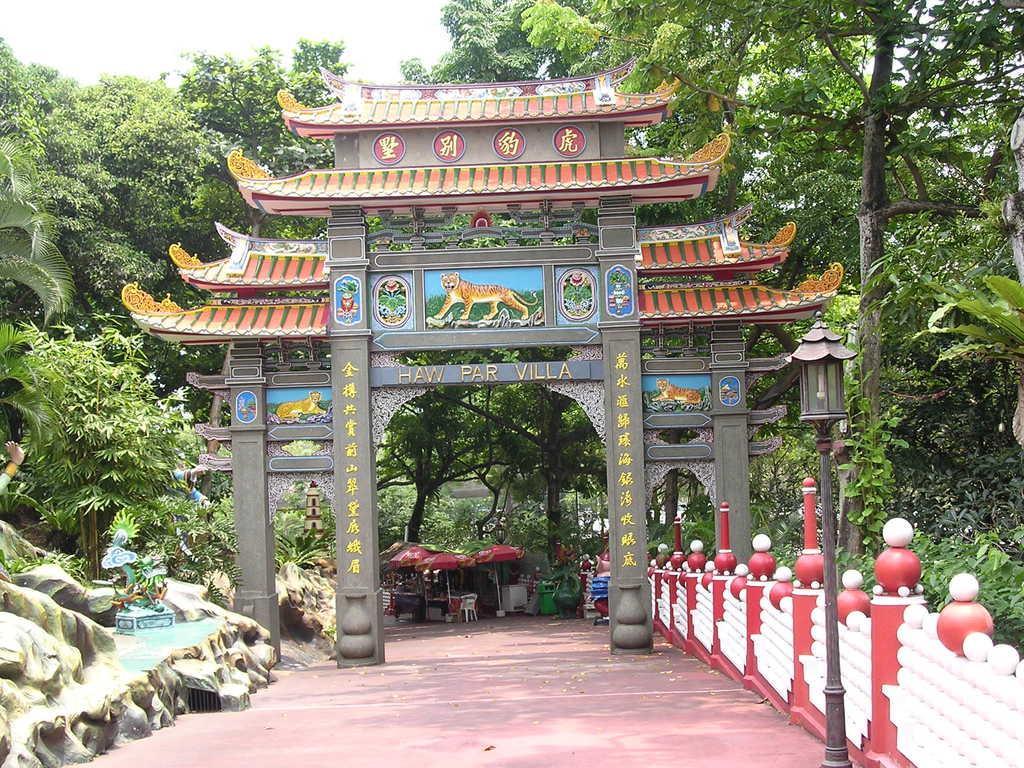How would you summarize this image in a sentence or two? In this image I see the arch on which there is art and I see few words written and I see the path and I see the fencing which is of red and white in color and I see a pole over here and I see number of trees and few stalls over here and I see the sky. 